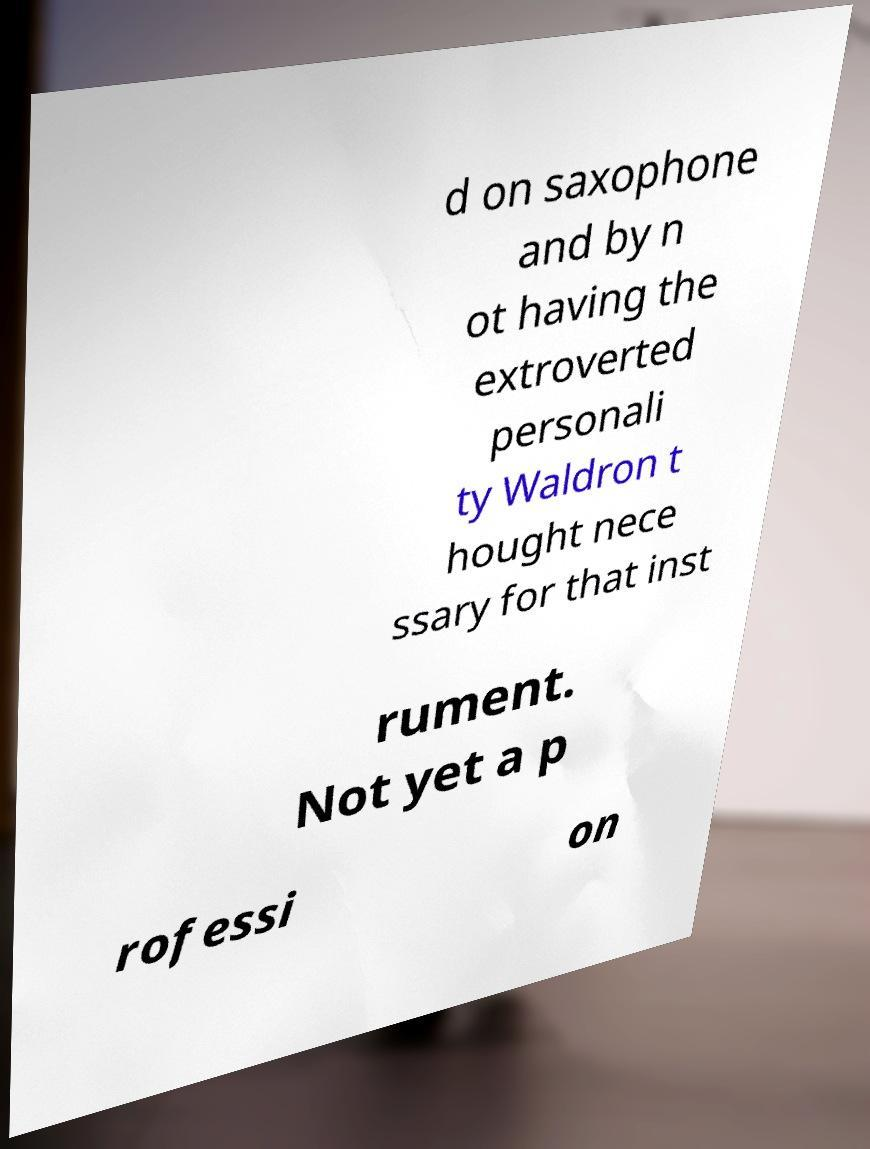I need the written content from this picture converted into text. Can you do that? d on saxophone and by n ot having the extroverted personali ty Waldron t hought nece ssary for that inst rument. Not yet a p rofessi on 